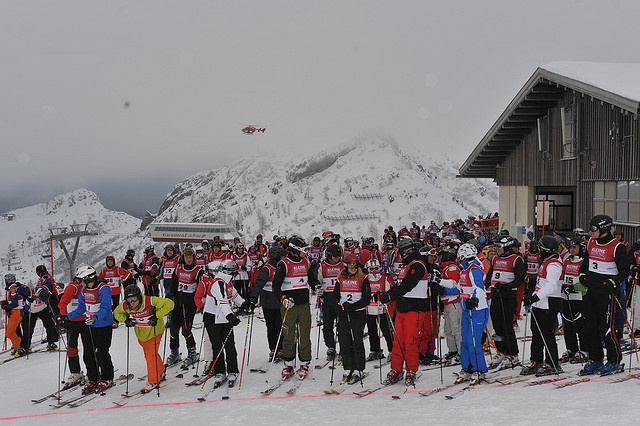Describe the objects in this image and their specific colors. I can see people in darkgray, black, gray, and maroon tones, people in darkgray, black, brown, and maroon tones, people in darkgray, black, gray, and maroon tones, people in darkgray, black, navy, and blue tones, and people in darkgray, black, gray, and maroon tones in this image. 